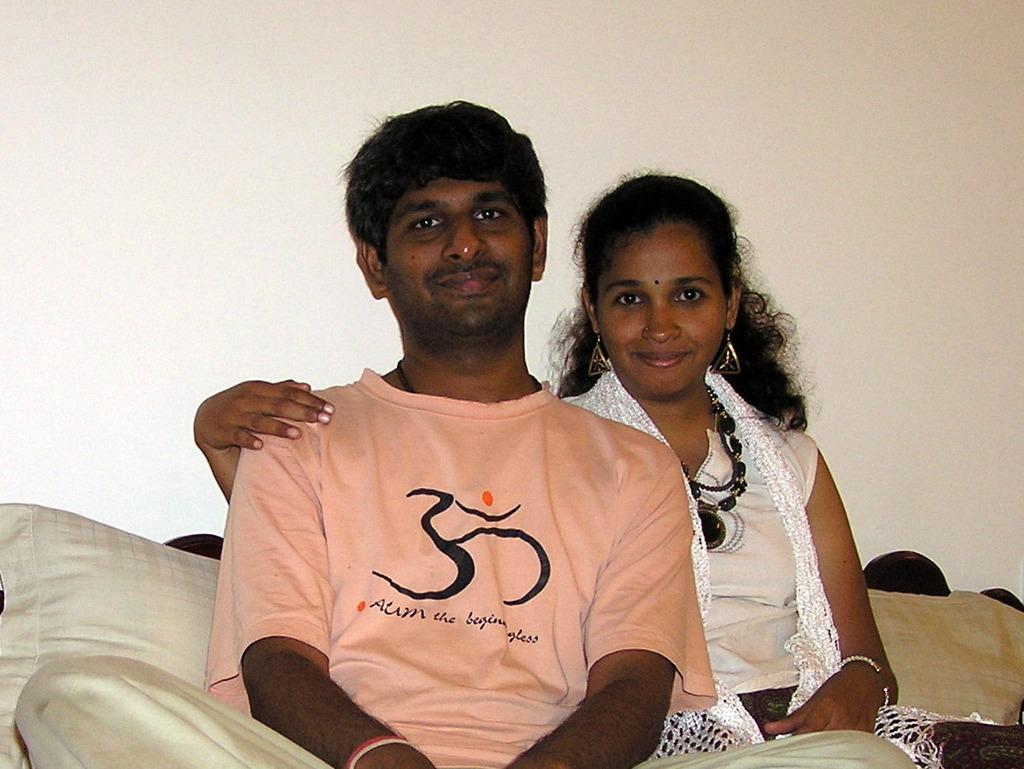Could you give a brief overview of what you see in this image? In the image I can see a man and a woman are sitting on a couch which is cream in color. In the background I can see the cream colored wall. 